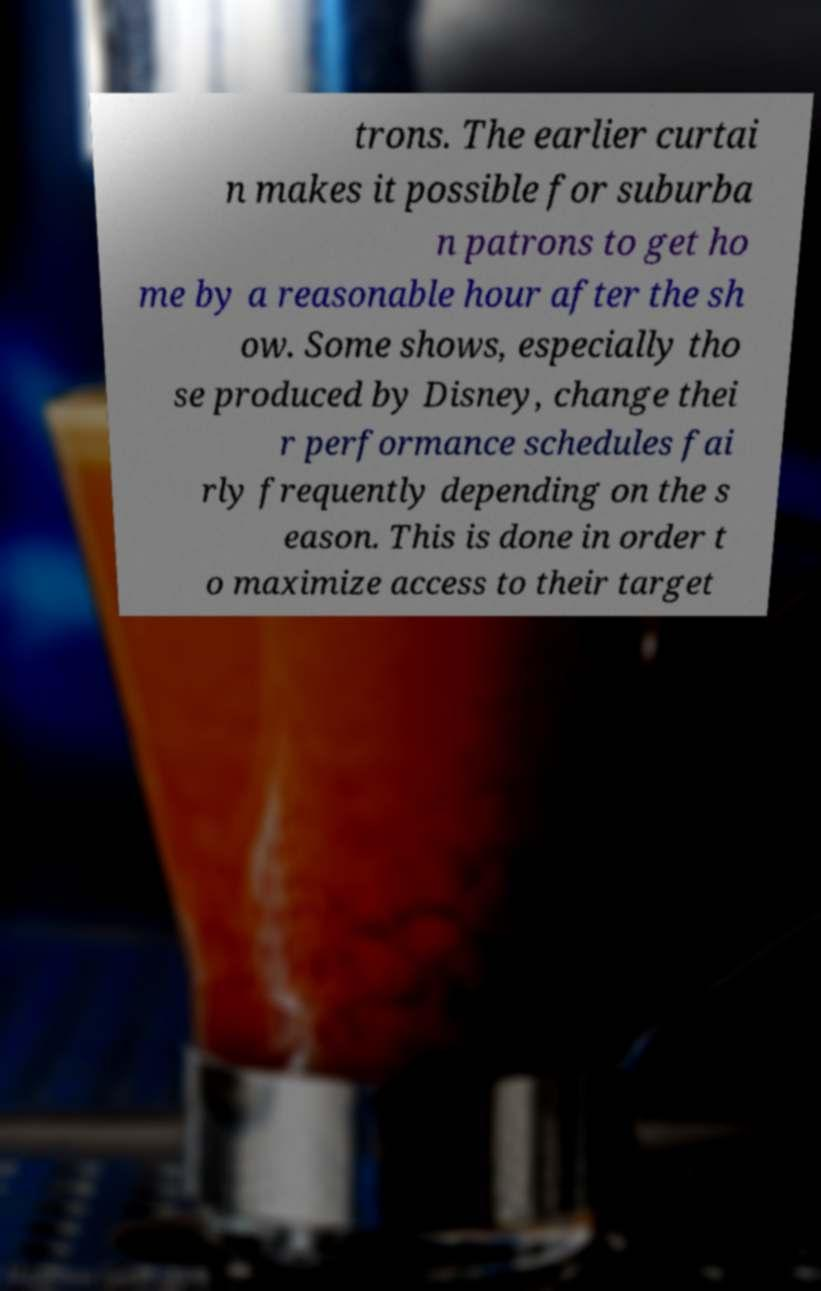For documentation purposes, I need the text within this image transcribed. Could you provide that? trons. The earlier curtai n makes it possible for suburba n patrons to get ho me by a reasonable hour after the sh ow. Some shows, especially tho se produced by Disney, change thei r performance schedules fai rly frequently depending on the s eason. This is done in order t o maximize access to their target 